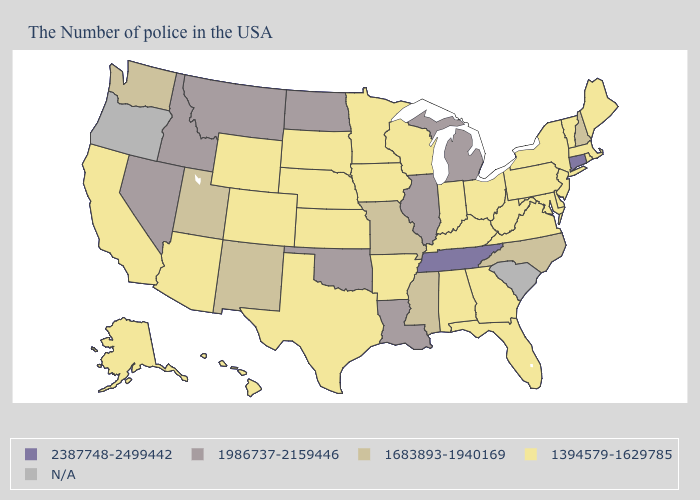Does the first symbol in the legend represent the smallest category?
Keep it brief. No. What is the highest value in the South ?
Quick response, please. 2387748-2499442. What is the value of Virginia?
Be succinct. 1394579-1629785. What is the value of Michigan?
Write a very short answer. 1986737-2159446. What is the value of Maine?
Concise answer only. 1394579-1629785. Which states have the highest value in the USA?
Quick response, please. Connecticut, Tennessee. How many symbols are there in the legend?
Write a very short answer. 5. What is the highest value in the MidWest ?
Quick response, please. 1986737-2159446. Does Montana have the lowest value in the USA?
Write a very short answer. No. What is the highest value in states that border Washington?
Write a very short answer. 1986737-2159446. What is the value of New Jersey?
Answer briefly. 1394579-1629785. Which states have the lowest value in the Northeast?
Short answer required. Maine, Massachusetts, Rhode Island, Vermont, New York, New Jersey, Pennsylvania. Name the states that have a value in the range N/A?
Give a very brief answer. South Carolina, Oregon. What is the value of Maine?
Keep it brief. 1394579-1629785. 